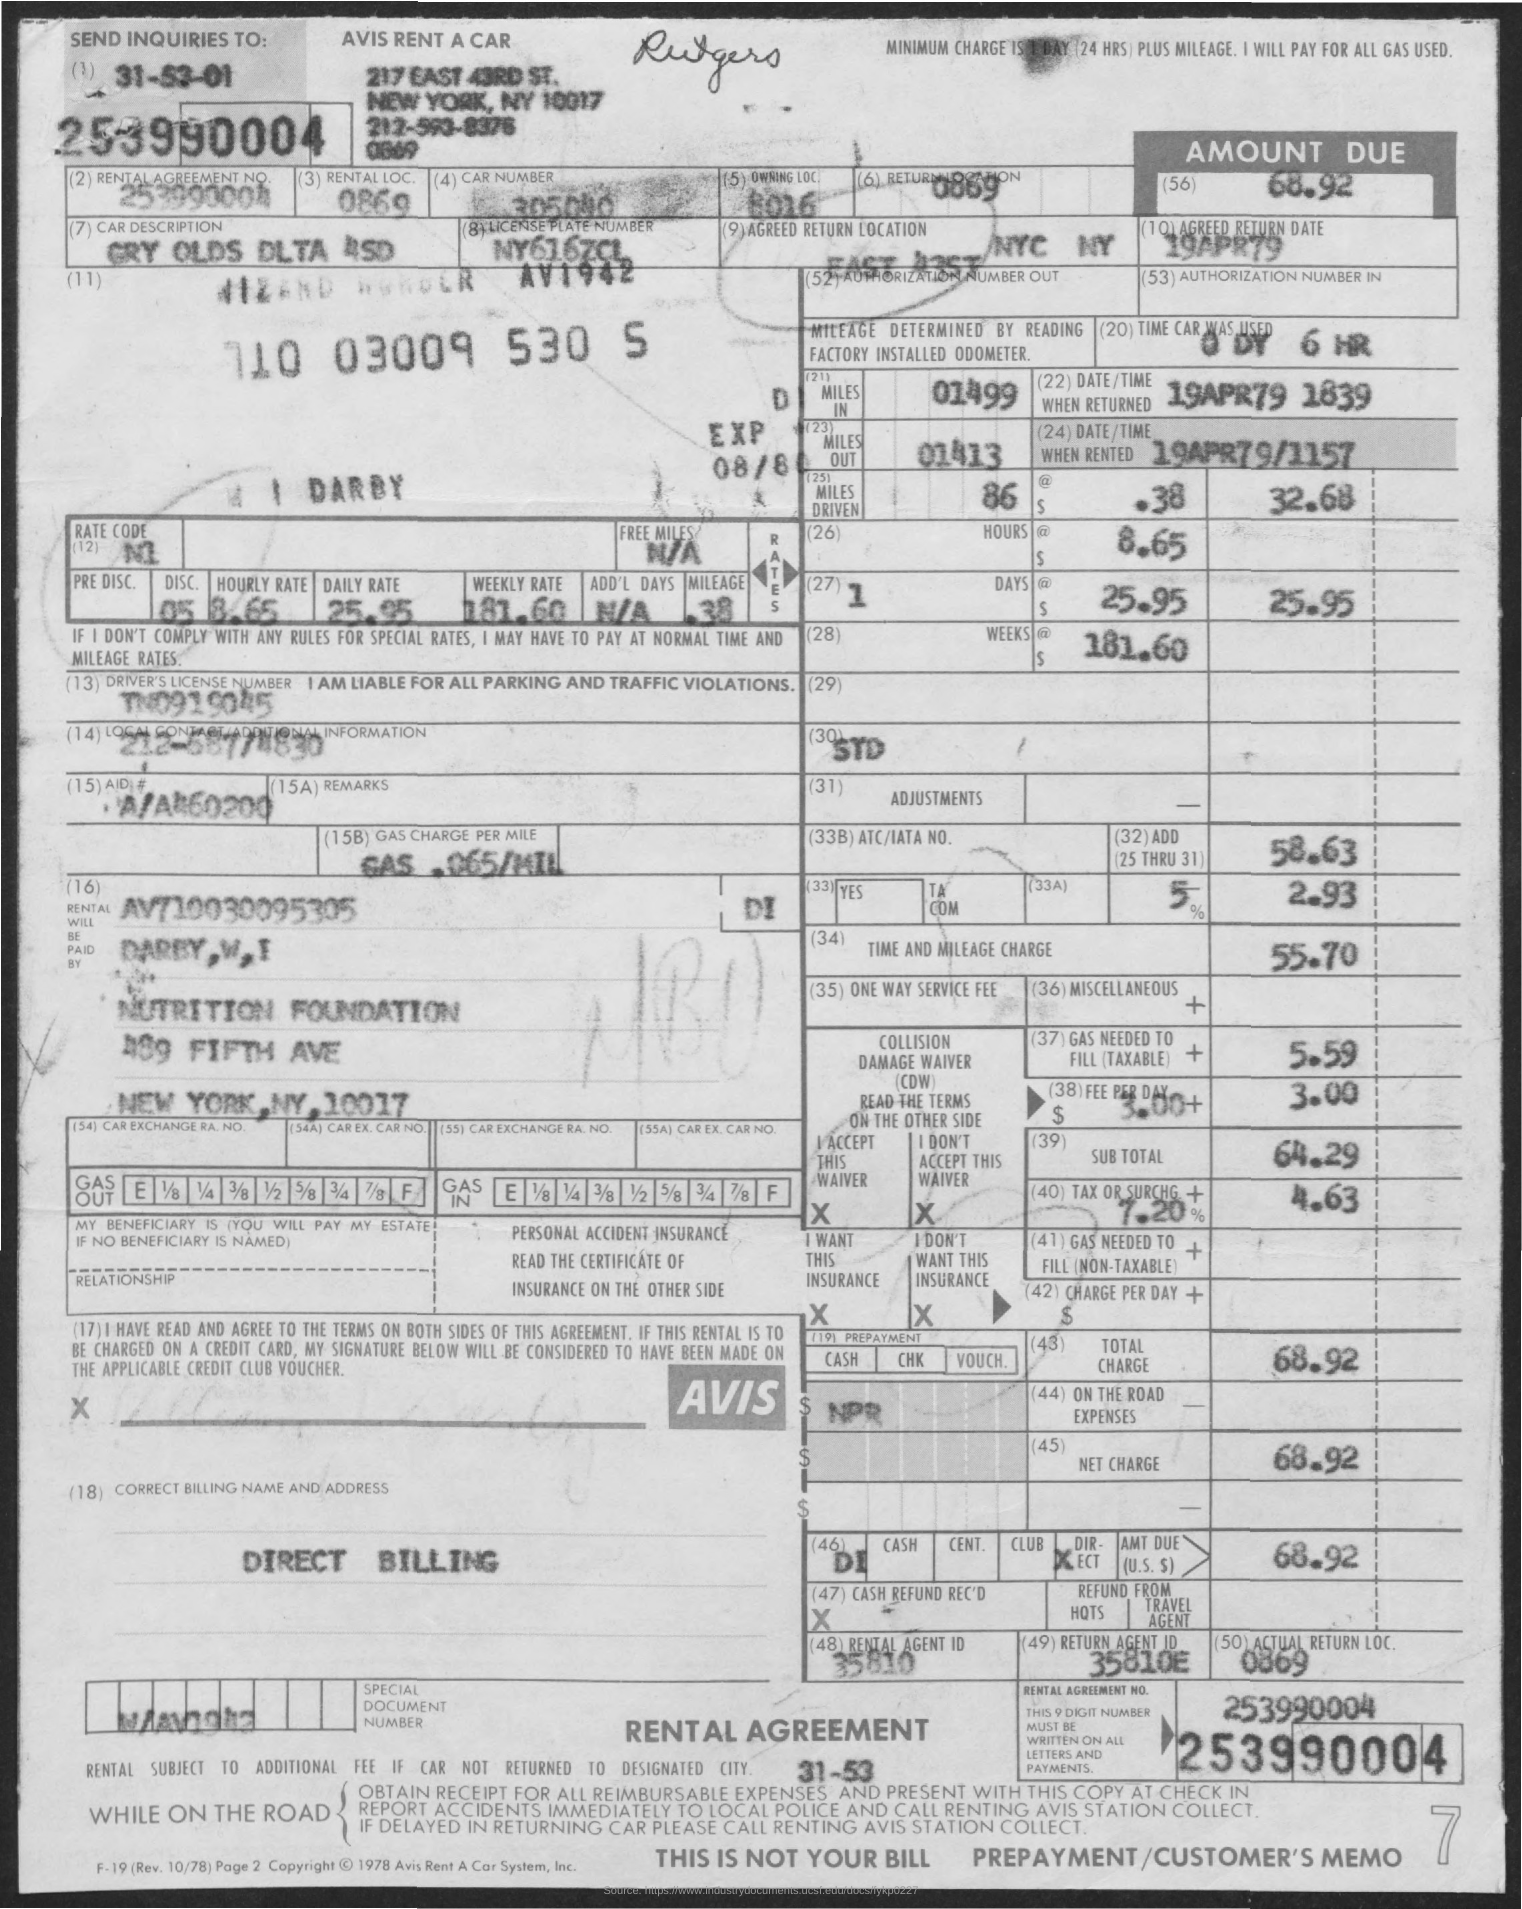What is the rental agreement no.?
Make the answer very short. 253990004. 